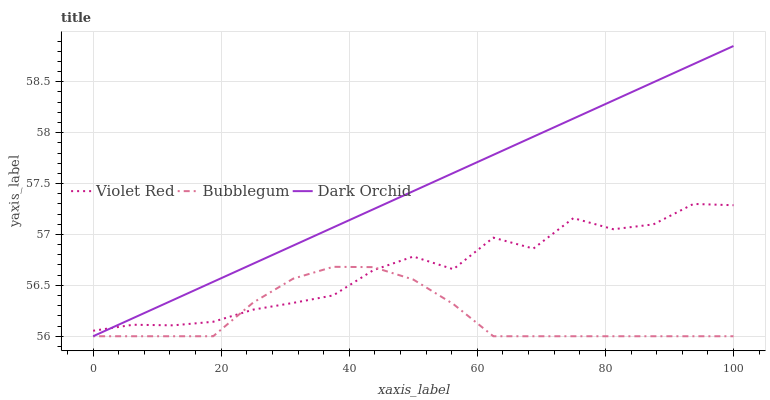Does Bubblegum have the minimum area under the curve?
Answer yes or no. Yes. Does Dark Orchid have the maximum area under the curve?
Answer yes or no. Yes. Does Dark Orchid have the minimum area under the curve?
Answer yes or no. No. Does Bubblegum have the maximum area under the curve?
Answer yes or no. No. Is Dark Orchid the smoothest?
Answer yes or no. Yes. Is Violet Red the roughest?
Answer yes or no. Yes. Is Bubblegum the smoothest?
Answer yes or no. No. Is Bubblegum the roughest?
Answer yes or no. No. Does Dark Orchid have the lowest value?
Answer yes or no. Yes. Does Dark Orchid have the highest value?
Answer yes or no. Yes. Does Bubblegum have the highest value?
Answer yes or no. No. Does Violet Red intersect Dark Orchid?
Answer yes or no. Yes. Is Violet Red less than Dark Orchid?
Answer yes or no. No. Is Violet Red greater than Dark Orchid?
Answer yes or no. No. 